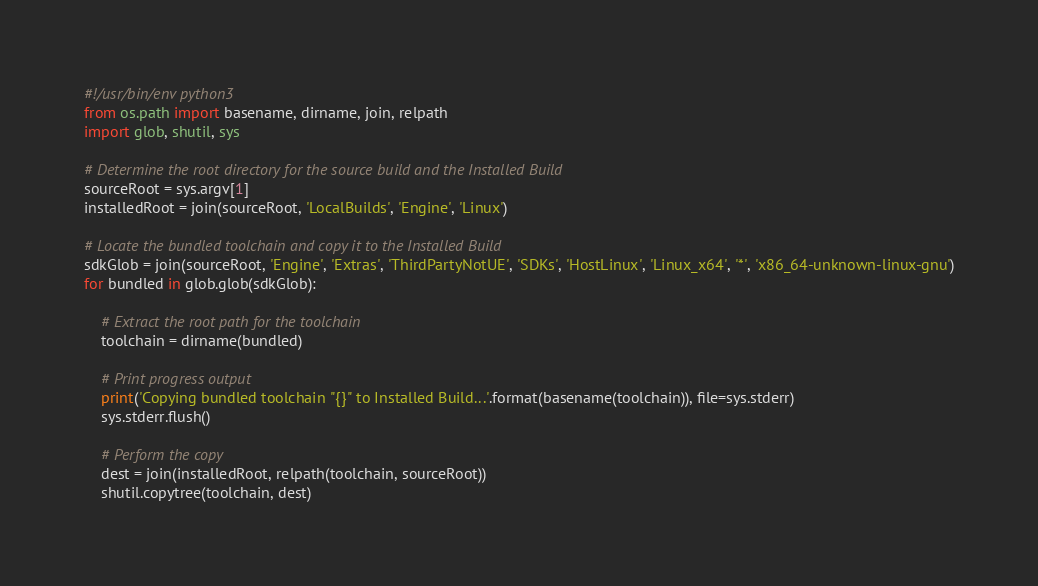Convert code to text. <code><loc_0><loc_0><loc_500><loc_500><_Python_>#!/usr/bin/env python3
from os.path import basename, dirname, join, relpath
import glob, shutil, sys

# Determine the root directory for the source build and the Installed Build
sourceRoot = sys.argv[1]
installedRoot = join(sourceRoot, 'LocalBuilds', 'Engine', 'Linux')

# Locate the bundled toolchain and copy it to the Installed Build
sdkGlob = join(sourceRoot, 'Engine', 'Extras', 'ThirdPartyNotUE', 'SDKs', 'HostLinux', 'Linux_x64', '*', 'x86_64-unknown-linux-gnu')
for bundled in glob.glob(sdkGlob):
	
	# Extract the root path for the toolchain
	toolchain = dirname(bundled)
	
	# Print progress output
	print('Copying bundled toolchain "{}" to Installed Build...'.format(basename(toolchain)), file=sys.stderr)
	sys.stderr.flush()
	
	# Perform the copy
	dest = join(installedRoot, relpath(toolchain, sourceRoot))
	shutil.copytree(toolchain, dest)
</code> 